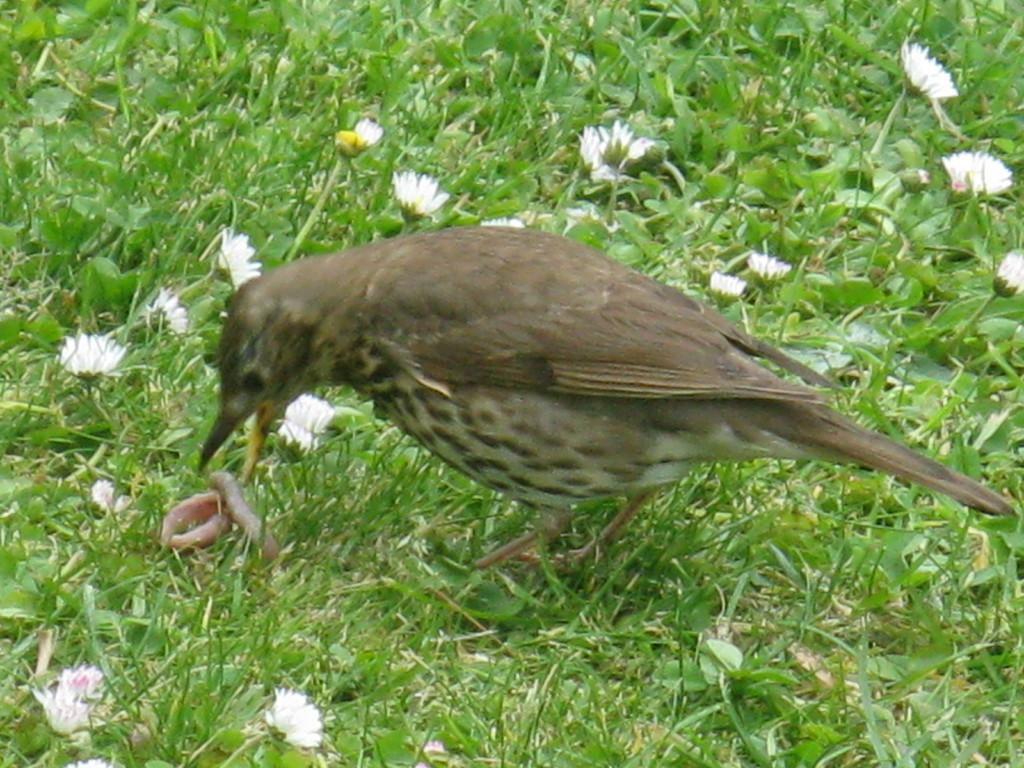What type of vegetation is present in the image? There is grass in the image. What color are the flowers in the image? The flowers in the image are white-colored. What animal can be seen in the center of the image? There is a bird in the center of the image. What other living organism can be seen in the center of the image? There is an insect in the center of the image. What type of silk is being used as a caption for the image? There is no silk or caption present in the image. What type of animals can be seen at the zoo in the image? There is no zoo or animals present in the image; it features a bird and an insect in a natural setting. 